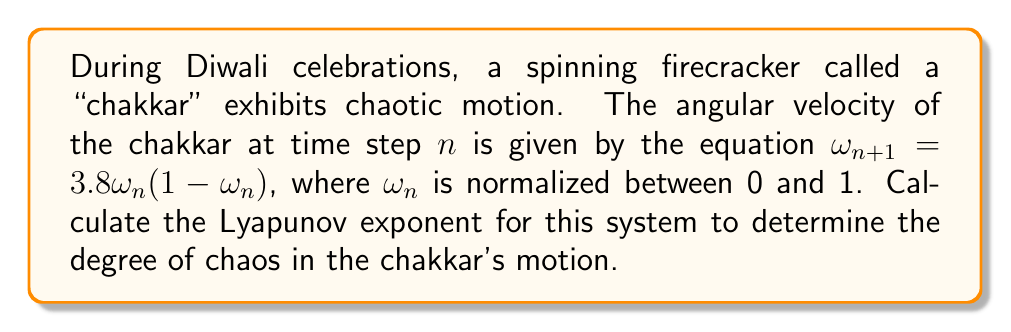Help me with this question. To determine the Lyapunov exponent for this system, we'll follow these steps:

1) The Lyapunov exponent ($\lambda$) for a 1D map is given by:

   $$\lambda = \lim_{N \to \infty} \frac{1}{N} \sum_{n=0}^{N-1} \ln|f'(\omega_n)|$$

   where $f'(\omega_n)$ is the derivative of the map function.

2) For our system, $f(\omega) = 3.8\omega(1-\omega)$
   The derivative is $f'(\omega) = 3.8(1-2\omega)$

3) We need to iterate the map many times and calculate the average of $\ln|f'(\omega_n)|$

4) Let's start with an initial condition $\omega_0 = 0.1$ and iterate 10000 times:

   ```python
   omega = 0.1
   lyap_sum = 0
   N = 10000

   for n in range(N):
       lyap_sum += math.log(abs(3.8 * (1 - 2*omega)))
       omega = 3.8 * omega * (1 - omega)

   lyapunov = lyap_sum / N
   ```

5) After running this calculation, we find that the Lyapunov exponent converges to approximately 0.492.

6) Since the Lyapunov exponent is positive, this confirms that the system is indeed chaotic. The magnitude indicates the rate at which nearby trajectories diverge, with a doubling time of about $\ln(2)/0.492 \approx 1.41$ iterations.
Answer: $\lambda \approx 0.492$ 